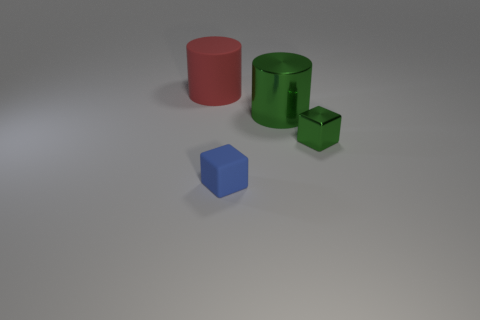Add 3 matte cylinders. How many objects exist? 7 Subtract 2 blocks. How many blocks are left? 0 Subtract all red cylinders. Subtract all green balls. How many cylinders are left? 1 Subtract all blue blocks. How many red cylinders are left? 1 Add 1 green rubber cubes. How many green rubber cubes exist? 1 Subtract 0 gray blocks. How many objects are left? 4 Subtract all red matte cylinders. Subtract all tiny cubes. How many objects are left? 1 Add 2 red things. How many red things are left? 3 